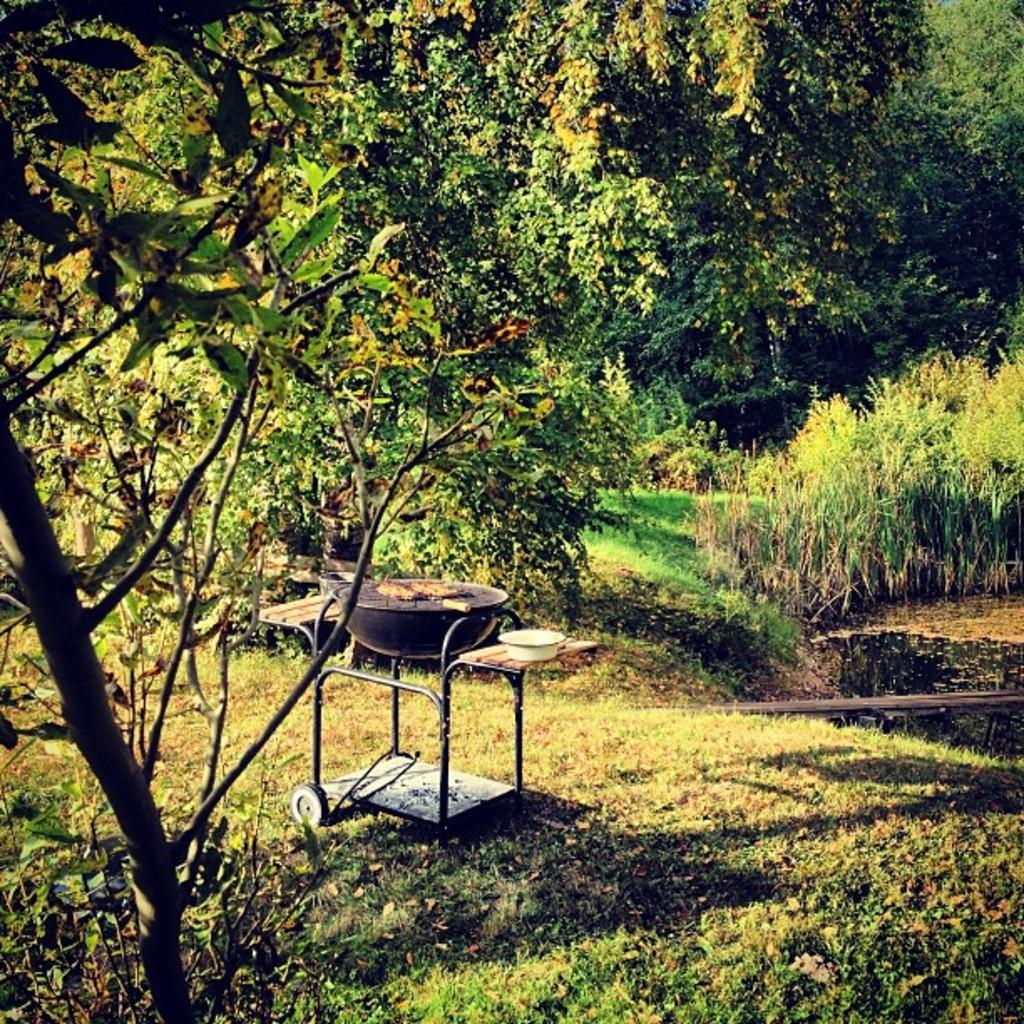What type of vegetation can be seen in the image? There are trees in the image. What natural element is visible in the image? There is water visible in the image. What cooking appliance is present in the image? There is a barbecue on a trolley in the image. How many matches are in the stocking hanging from the tree in the image? There are no matches or stockings present in the image. What type of fire can be seen in the image? There is no fire present in the image. 